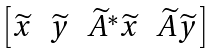<formula> <loc_0><loc_0><loc_500><loc_500>\begin{bmatrix} \widetilde { x } & \widetilde { y } & \widetilde { A } ^ { * } \widetilde { x } & \widetilde { A } \widetilde { y } \end{bmatrix}</formula> 